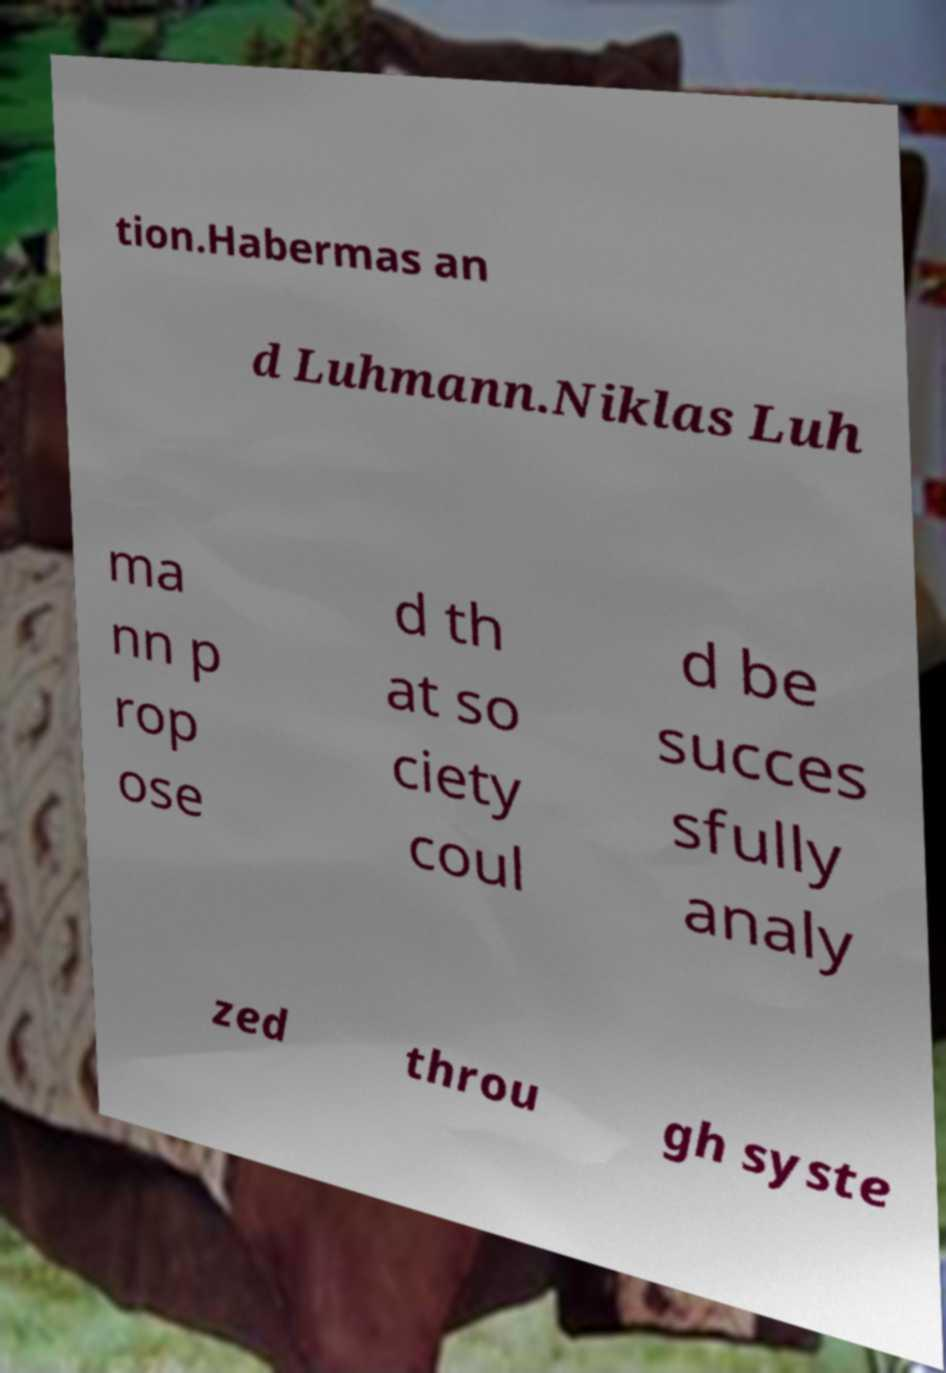Please read and relay the text visible in this image. What does it say? tion.Habermas an d Luhmann.Niklas Luh ma nn p rop ose d th at so ciety coul d be succes sfully analy zed throu gh syste 